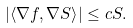<formula> <loc_0><loc_0><loc_500><loc_500>\left | \left \langle \nabla f , \nabla S \right \rangle \right | \leq c S .</formula> 